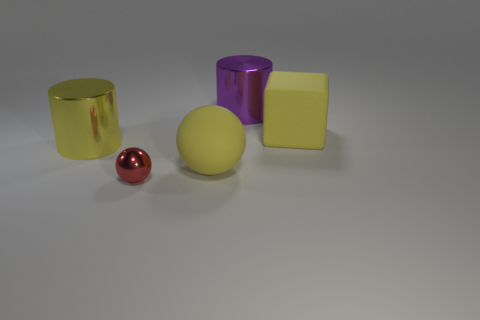Is there anything else that is the same size as the red object?
Your answer should be very brief. No. Does the rubber sphere have the same size as the yellow matte block?
Ensure brevity in your answer.  Yes. How many objects are red objects or yellow matte spheres?
Offer a very short reply. 2. What size is the metal thing that is in front of the yellow rubber thing that is in front of the big yellow metallic cylinder?
Your response must be concise. Small. The purple metallic cylinder has what size?
Make the answer very short. Large. There is a thing that is both on the left side of the big purple metallic cylinder and on the right side of the small red shiny object; what is its shape?
Your response must be concise. Sphere. There is another thing that is the same shape as the large purple thing; what color is it?
Your answer should be very brief. Yellow. How many objects are either yellow matte things that are in front of the yellow metallic object or yellow objects that are left of the big rubber cube?
Your answer should be compact. 2. There is a red shiny object; what shape is it?
Provide a short and direct response. Sphere. There is a metallic object that is the same color as the rubber block; what shape is it?
Make the answer very short. Cylinder. 